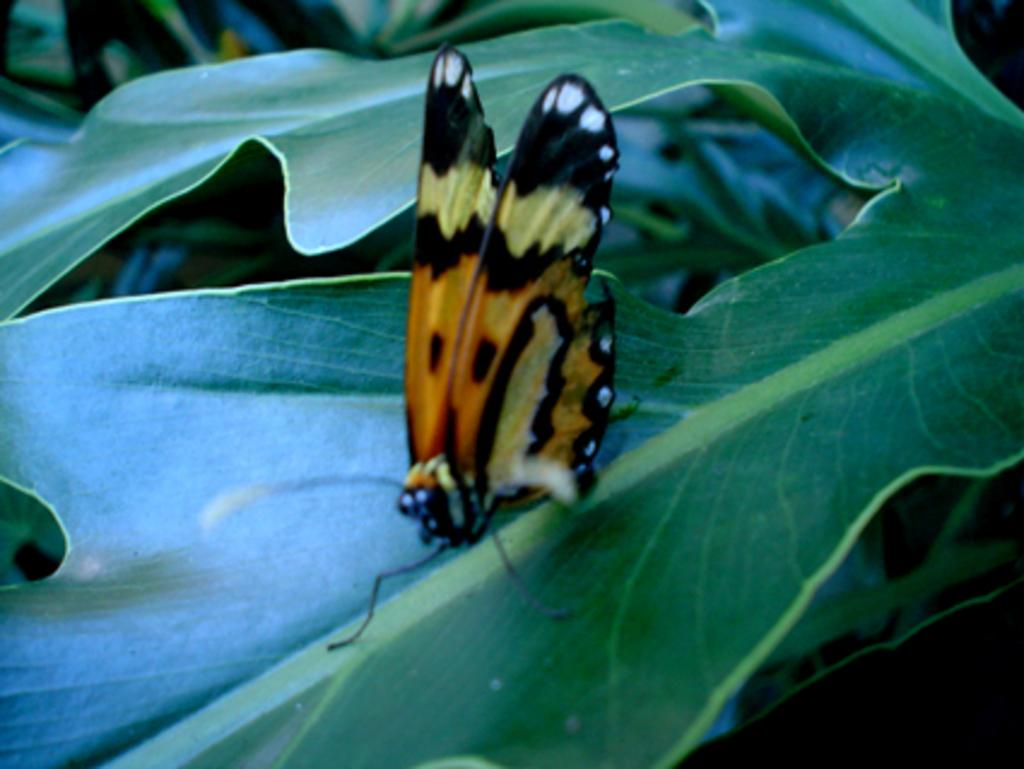What is the main subject of the image? There is a butterfly in the image. Can you describe the color of the butterfly? The butterfly is brown and black in color. Where is the butterfly located in the image? The butterfly is on a leaf. What can be seen in the background of the image? There are green leaves in the background of the image. How many babies are waving good-bye in the image? There are no babies or any indication of waving good-bye in the image; it features a butterfly on a leaf. 